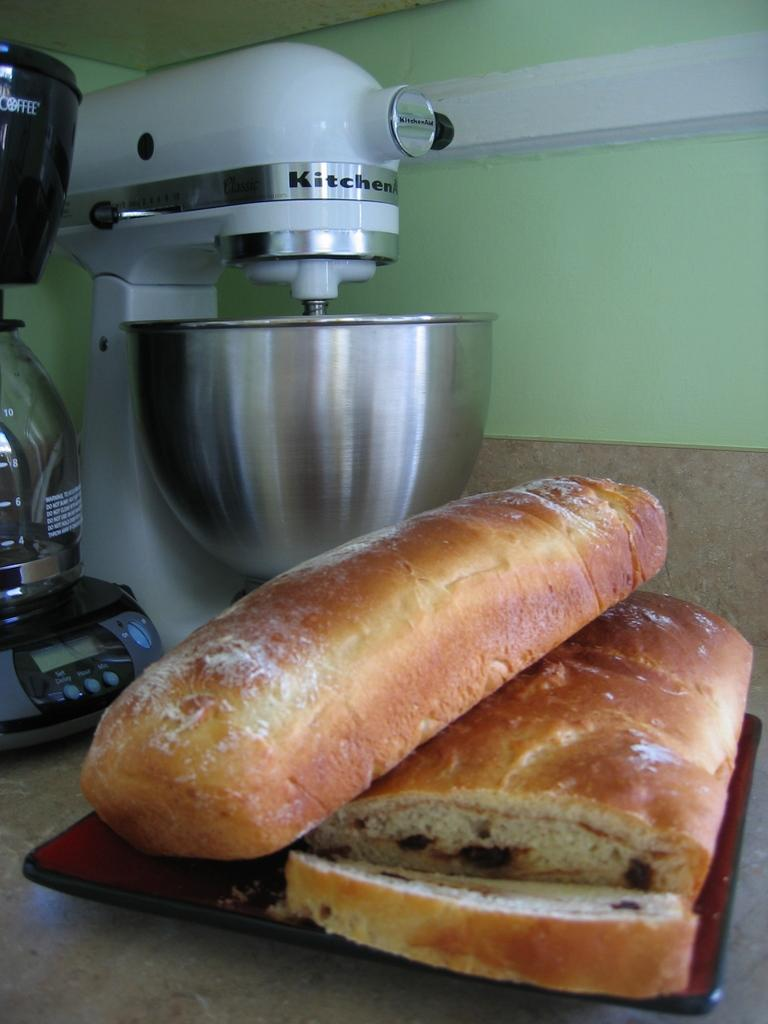<image>
Summarize the visual content of the image. the word kitchen is on the white machine 